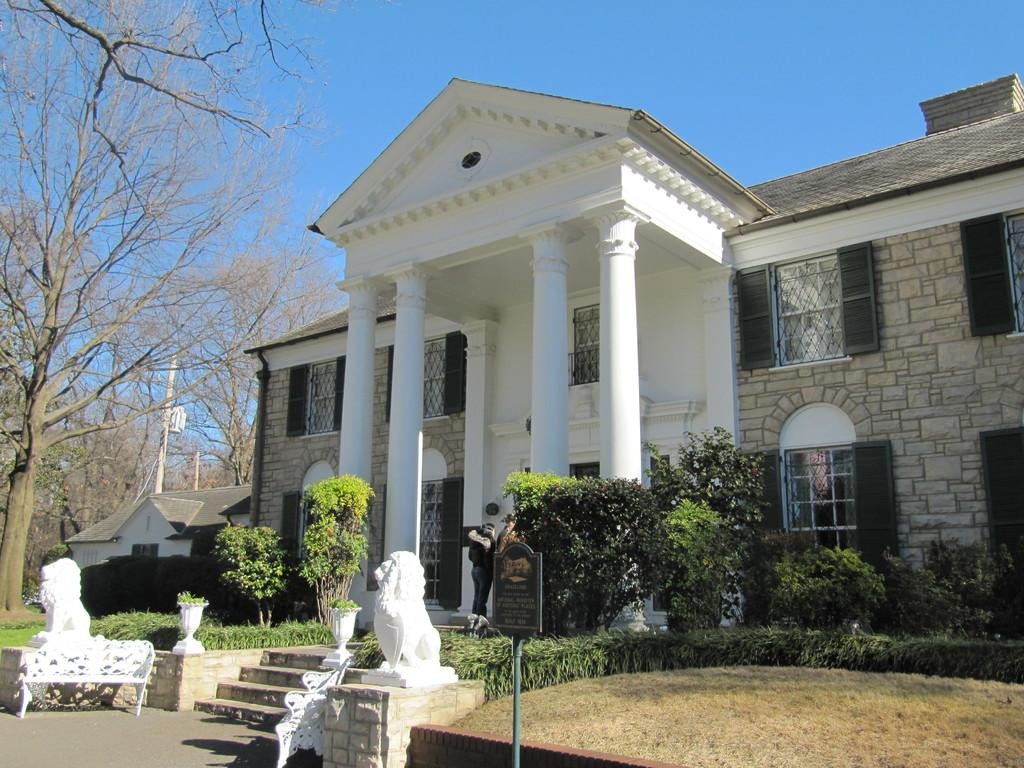What type of structure is visible in the image? There is a building in the image. What architectural features can be seen on the building? The building has windows, poles, a board, and pillars. What type of vegetation is present in the image? There are plants, trees, and grass in the image. Are there any artistic elements in the image? Yes, there are sculptures in the image. How many people are in the image? There are two persons in the image. What can be seen in the background of the image? The sky is visible in the background of the image. What is the tendency of the carpenter in the image? There is no carpenter present in the image, so it is not possible to determine their tendency. What type of home is depicted in the image? The image does not show a home; it features a building with various architectural elements and vegetation. 